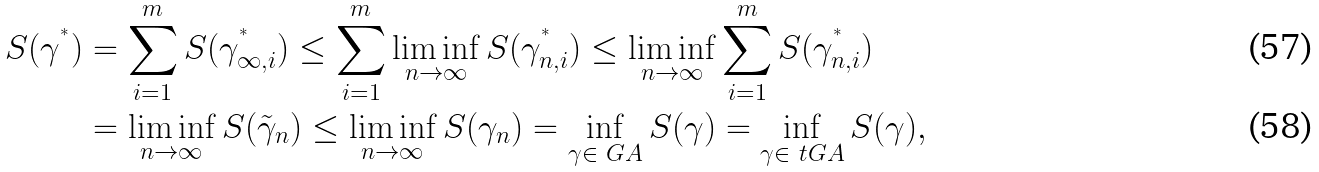Convert formula to latex. <formula><loc_0><loc_0><loc_500><loc_500>S ( \gamma ^ { ^ { * } } ) & = \sum _ { i = 1 } ^ { m } S ( \gamma ^ { ^ { * } } _ { \infty , i } ) \leq \sum _ { i = 1 } ^ { m } \liminf _ { n \to \infty } S ( \gamma ^ { ^ { * } } _ { n , i } ) \leq \liminf _ { n \to \infty } \sum _ { i = 1 } ^ { m } S ( \gamma ^ { ^ { * } } _ { n , i } ) \\ & = \liminf _ { n \to \infty } S ( \tilde { \gamma } _ { n } ) \leq \liminf _ { n \to \infty } S ( \gamma _ { n } ) = \inf _ { \gamma \in \ G A } S ( \gamma ) = \inf _ { \gamma \in \ t G A } S ( \gamma ) ,</formula> 